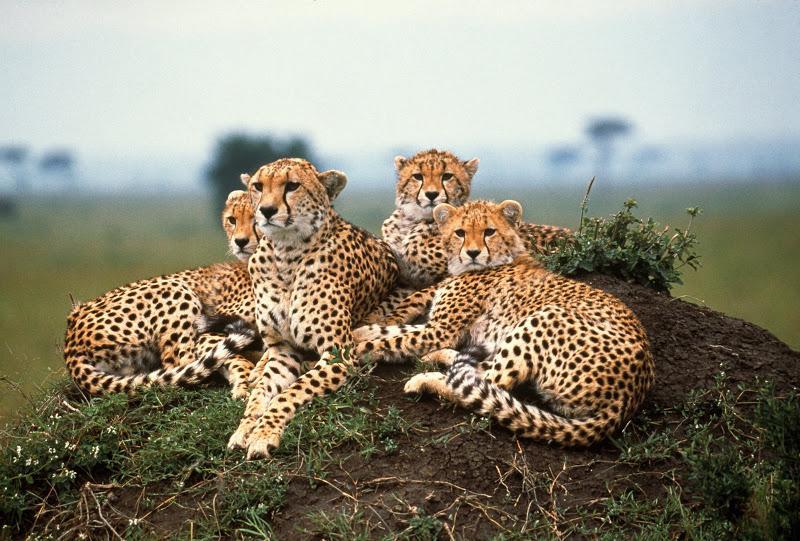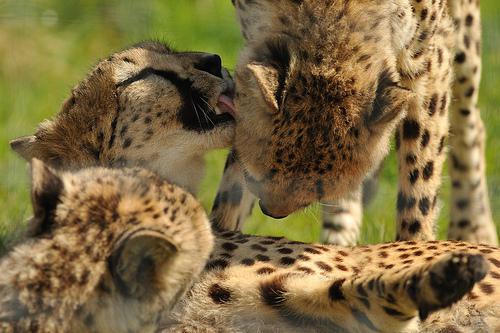The first image is the image on the left, the second image is the image on the right. For the images shown, is this caption "In one of the images, you can see one of the animal's tongues." true? Answer yes or no. Yes. The first image is the image on the left, the second image is the image on the right. For the images shown, is this caption "There are more spotted wild cats in the left image than in the right." true? Answer yes or no. Yes. 